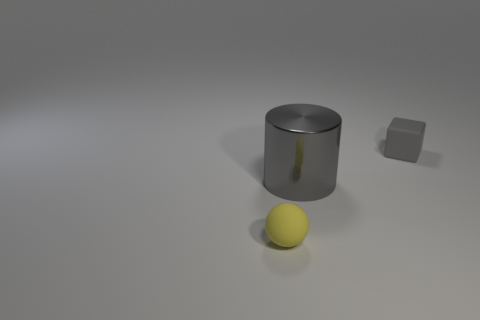Add 2 red shiny cubes. How many objects exist? 5 Subtract all red cylinders. How many purple balls are left? 0 Subtract all matte objects. Subtract all large metal objects. How many objects are left? 0 Add 1 metal things. How many metal things are left? 2 Add 1 gray cylinders. How many gray cylinders exist? 2 Subtract 0 purple balls. How many objects are left? 3 Subtract all cylinders. How many objects are left? 2 Subtract 1 blocks. How many blocks are left? 0 Subtract all purple cubes. Subtract all blue cylinders. How many cubes are left? 1 